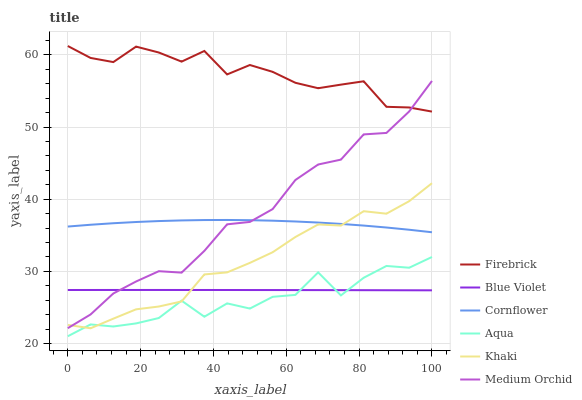Does Aqua have the minimum area under the curve?
Answer yes or no. Yes. Does Firebrick have the maximum area under the curve?
Answer yes or no. Yes. Does Khaki have the minimum area under the curve?
Answer yes or no. No. Does Khaki have the maximum area under the curve?
Answer yes or no. No. Is Blue Violet the smoothest?
Answer yes or no. Yes. Is Aqua the roughest?
Answer yes or no. Yes. Is Khaki the smoothest?
Answer yes or no. No. Is Khaki the roughest?
Answer yes or no. No. Does Aqua have the lowest value?
Answer yes or no. Yes. Does Khaki have the lowest value?
Answer yes or no. No. Does Firebrick have the highest value?
Answer yes or no. Yes. Does Khaki have the highest value?
Answer yes or no. No. Is Khaki less than Firebrick?
Answer yes or no. Yes. Is Cornflower greater than Blue Violet?
Answer yes or no. Yes. Does Blue Violet intersect Aqua?
Answer yes or no. Yes. Is Blue Violet less than Aqua?
Answer yes or no. No. Is Blue Violet greater than Aqua?
Answer yes or no. No. Does Khaki intersect Firebrick?
Answer yes or no. No. 